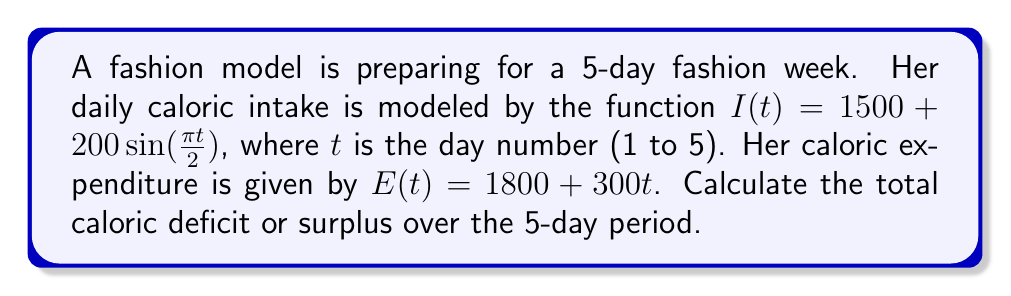Teach me how to tackle this problem. 1) To find the total caloric deficit or surplus, we need to calculate the difference between total intake and total expenditure over the 5 days.

2) Total caloric intake:
   $$\int_{1}^{5} I(t) dt = \int_{1}^{5} (1500 + 200\sin(\frac{\pi t}{2})) dt$$
   $$= [1500t - \frac{400}{\pi}\cos(\frac{\pi t}{2})]_{1}^{5}$$
   $$= (7500 - \frac{400}{\pi}\cos(\frac{5\pi}{2})) - (1500 - \frac{400}{\pi}\cos(\frac{\pi}{2}))$$
   $$= 6000 - \frac{400}{\pi}(0 - 0) = 6000$$

3) Total caloric expenditure:
   $$\int_{1}^{5} E(t) dt = \int_{1}^{5} (1800 + 300t) dt$$
   $$= [1800t + 150t^2]_{1}^{5}$$
   $$= (9000 + 3750) - (1800 + 150) = 10800$$

4) Caloric deficit = Total expenditure - Total intake
   $$10800 - 6000 = 4800$$

Therefore, the model will have a caloric deficit of 4800 calories over the 5-day period.
Answer: 4800 calorie deficit 